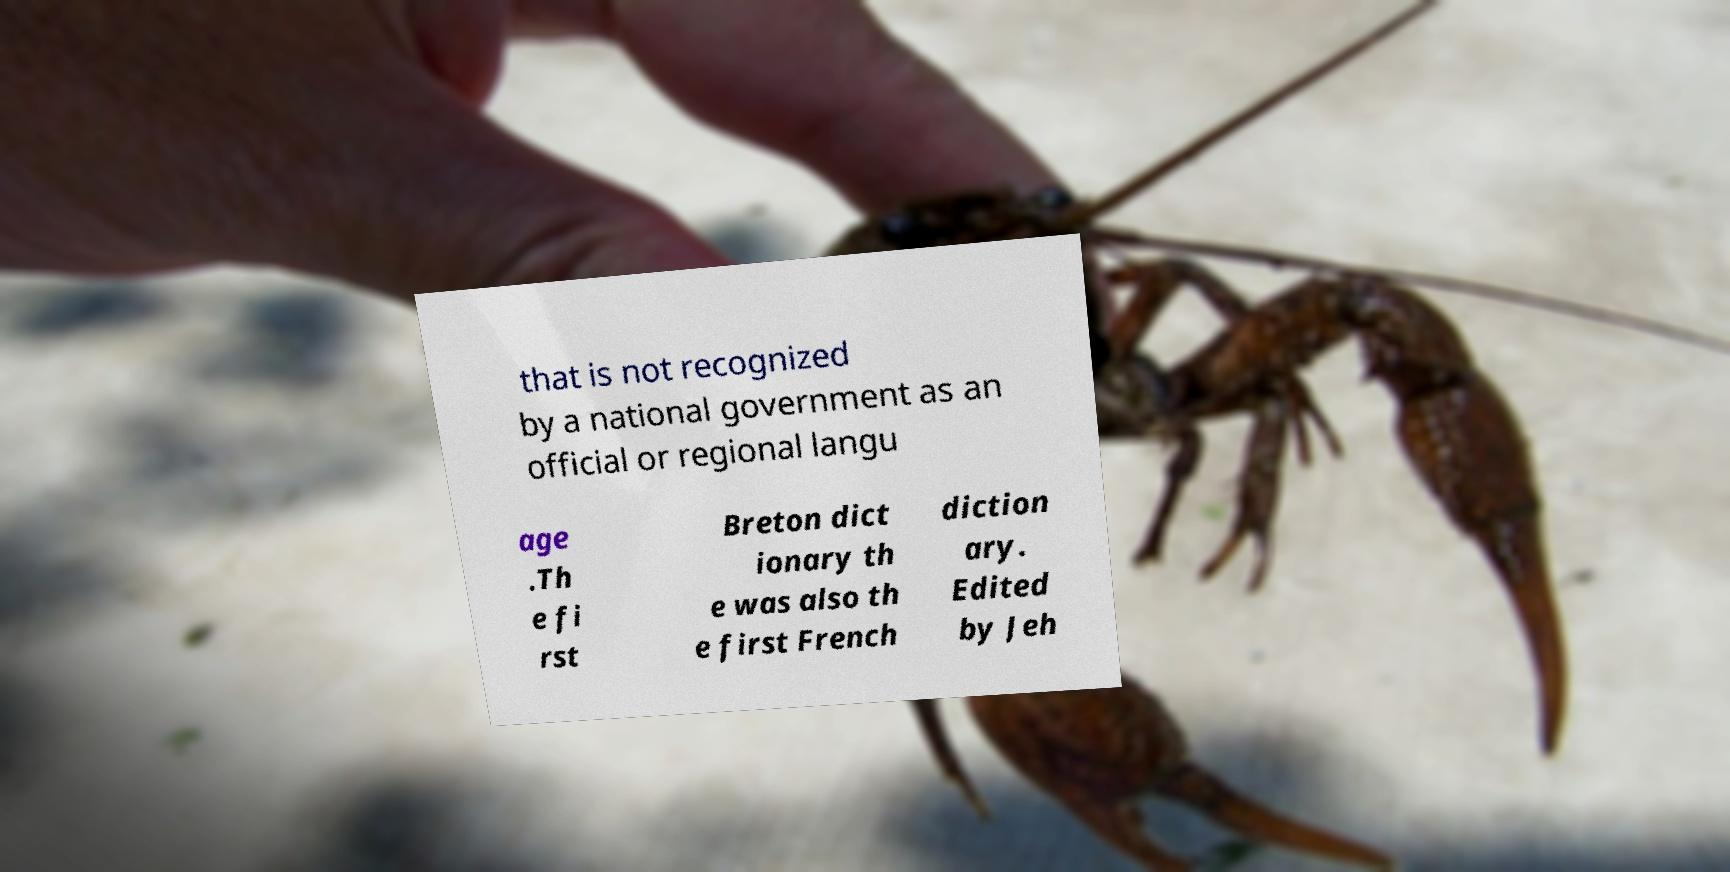Could you extract and type out the text from this image? that is not recognized by a national government as an official or regional langu age .Th e fi rst Breton dict ionary th e was also th e first French diction ary. Edited by Jeh 